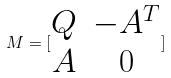<formula> <loc_0><loc_0><loc_500><loc_500>M = [ \begin{matrix} Q & - A ^ { T } \\ A & 0 \end{matrix} ]</formula> 